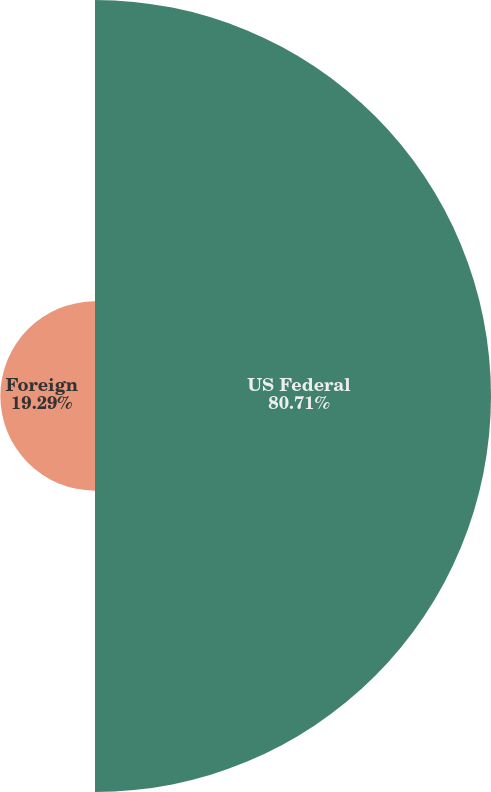Convert chart to OTSL. <chart><loc_0><loc_0><loc_500><loc_500><pie_chart><fcel>US Federal<fcel>Foreign<nl><fcel>80.71%<fcel>19.29%<nl></chart> 